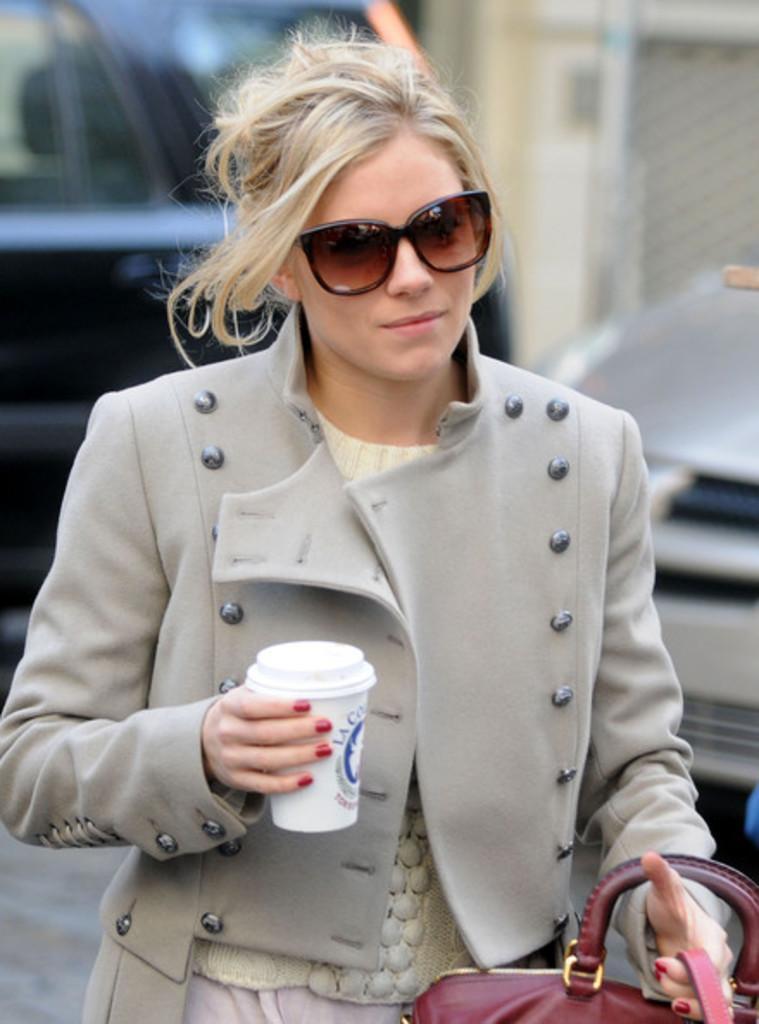In one or two sentences, can you explain what this image depicts? In this image i can see a woman standing holding a glass and a bag at the back ground i can see a car , a wall. 